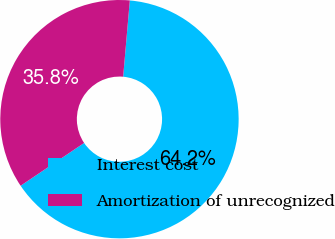Convert chart. <chart><loc_0><loc_0><loc_500><loc_500><pie_chart><fcel>Interest cost<fcel>Amortization of unrecognized<nl><fcel>64.18%<fcel>35.82%<nl></chart> 